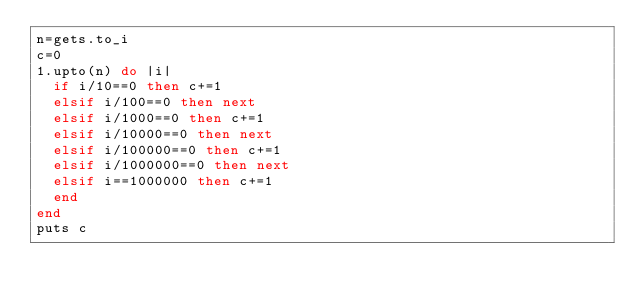Convert code to text. <code><loc_0><loc_0><loc_500><loc_500><_Ruby_>n=gets.to_i
c=0
1.upto(n) do |i|
  if i/10==0 then c+=1
  elsif i/100==0 then next
  elsif i/1000==0 then c+=1
  elsif i/10000==0 then next
  elsif i/100000==0 then c+=1
  elsif i/1000000==0 then next
  elsif i==1000000 then c+=1
  end
end
puts c
</code> 